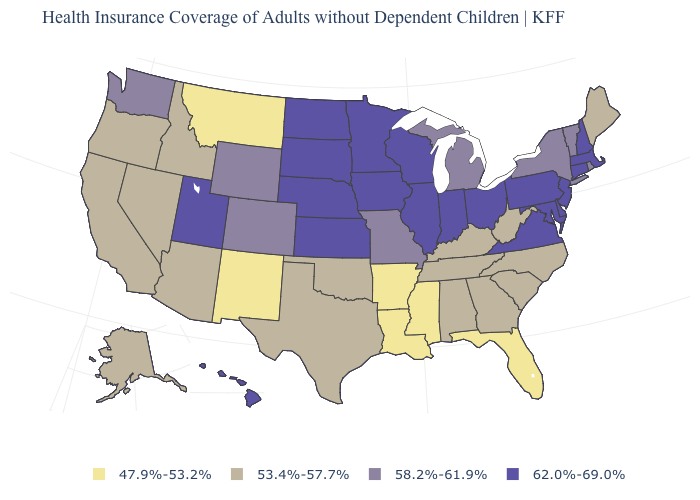What is the value of New York?
Keep it brief. 58.2%-61.9%. What is the value of Connecticut?
Give a very brief answer. 62.0%-69.0%. Among the states that border Rhode Island , which have the highest value?
Give a very brief answer. Connecticut, Massachusetts. Does South Dakota have the lowest value in the MidWest?
Short answer required. No. What is the value of Kansas?
Quick response, please. 62.0%-69.0%. Name the states that have a value in the range 53.4%-57.7%?
Give a very brief answer. Alabama, Alaska, Arizona, California, Georgia, Idaho, Kentucky, Maine, Nevada, North Carolina, Oklahoma, Oregon, South Carolina, Tennessee, Texas, West Virginia. What is the lowest value in the USA?
Answer briefly. 47.9%-53.2%. Does Maine have the highest value in the USA?
Write a very short answer. No. Among the states that border Missouri , does Oklahoma have the highest value?
Keep it brief. No. Does Arizona have the lowest value in the USA?
Write a very short answer. No. Among the states that border West Virginia , does Ohio have the highest value?
Quick response, please. Yes. Among the states that border Pennsylvania , does New York have the highest value?
Give a very brief answer. No. Name the states that have a value in the range 53.4%-57.7%?
Answer briefly. Alabama, Alaska, Arizona, California, Georgia, Idaho, Kentucky, Maine, Nevada, North Carolina, Oklahoma, Oregon, South Carolina, Tennessee, Texas, West Virginia. What is the value of Wisconsin?
Concise answer only. 62.0%-69.0%. What is the value of New Hampshire?
Short answer required. 62.0%-69.0%. 